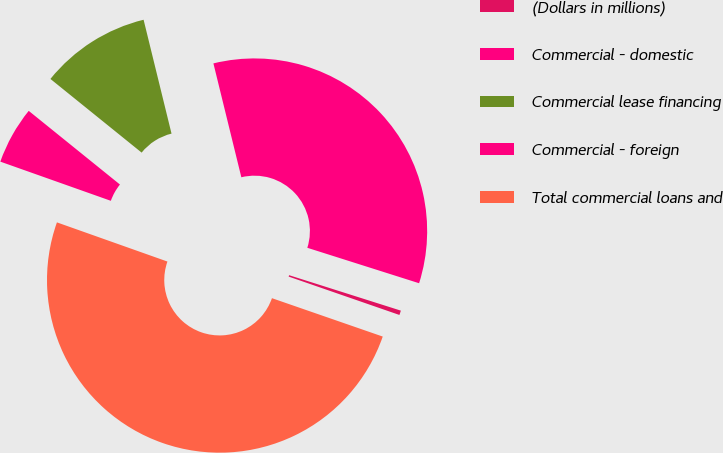<chart> <loc_0><loc_0><loc_500><loc_500><pie_chart><fcel>(Dollars in millions)<fcel>Commercial - domestic<fcel>Commercial lease financing<fcel>Commercial - foreign<fcel>Total commercial loans and<nl><fcel>0.42%<fcel>33.72%<fcel>10.36%<fcel>5.39%<fcel>50.12%<nl></chart> 